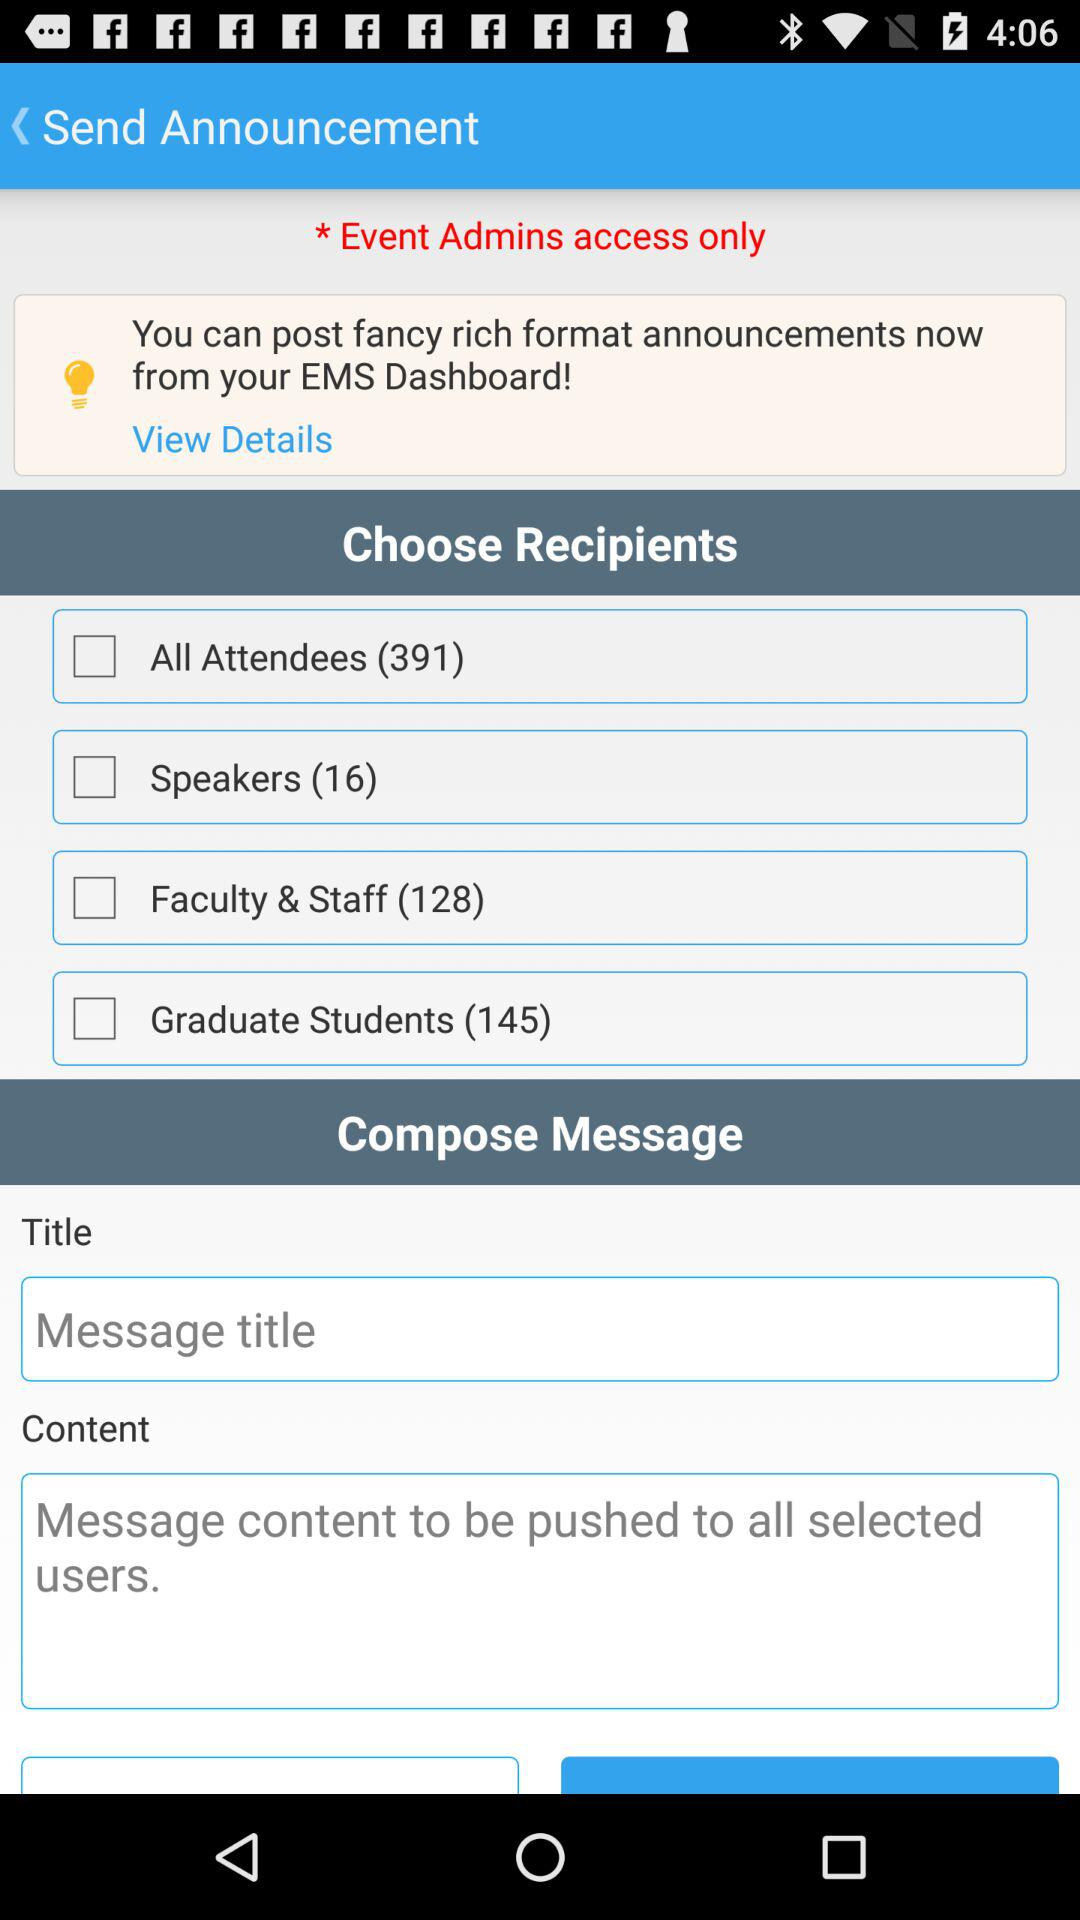Who can access the event?
When the provided information is insufficient, respond with <no answer>. <no answer> 